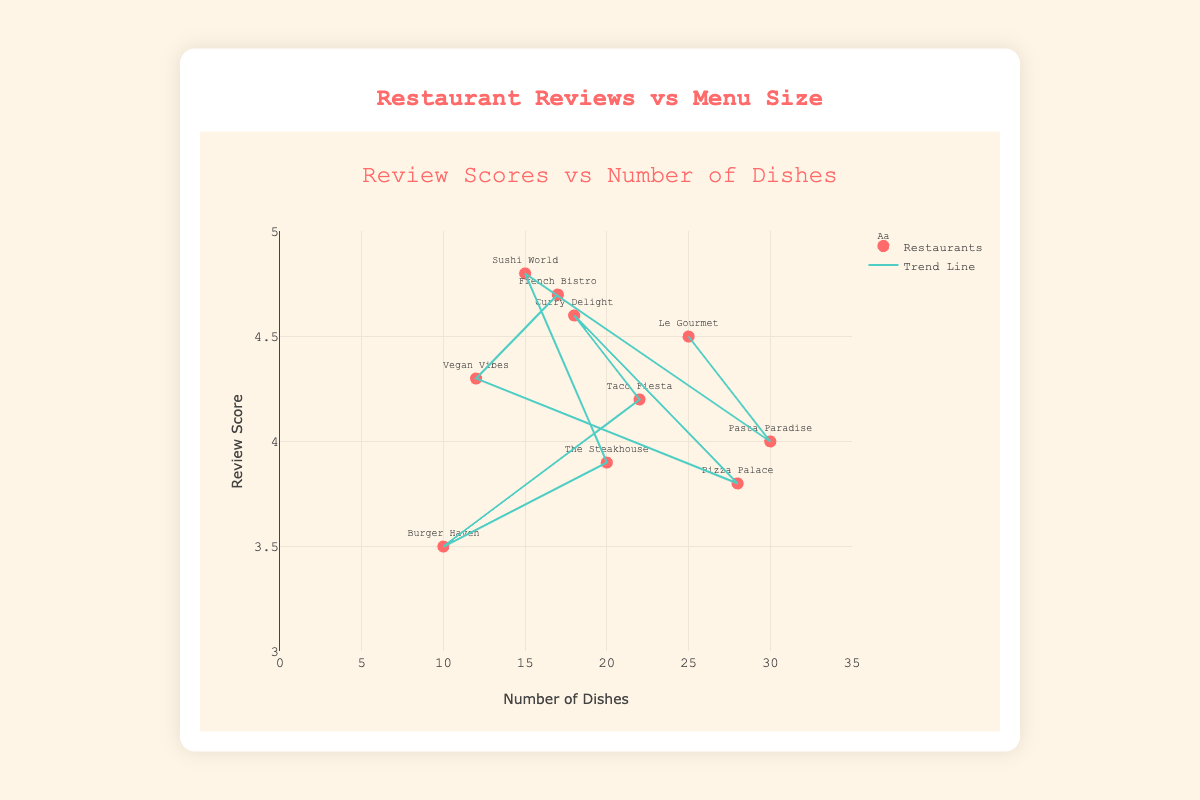How many restaurants are shown in the plot? Count each data point representing a restaurant in the plot. Each point corresponds to a restaurant, and there are 10 data points in total.
Answer: 10 Which restaurant has the highest review score? Look for the data point with the highest position on the y-axis. Sushi World has the highest review score of 4.8.
Answer: Sushi World Which restaurant has the fewest dishes? Look for the data point farthest to the left on the x-axis. Burger Haven has the fewest dishes with 10.
Answer: Burger Haven What is the general trend between the number of dishes and review scores? Observe the trend line that indicates the general relationship between the two variables. The trend line appears to be relatively flat, indicating no strong correlation.
Answer: No strong correlation How many restaurants have a review score greater than 4.5? Identify the points above the 4.5 mark on the y-axis. There are 3 restaurants: Sushi World, Curry Delight, and French Bistro.
Answer: 3 Which restaurant has more dishes, Pasta Paradise or Vegan Vibes? Compare the positions of Pasta Paradise and Vegan Vibes on the x-axis. Pasta Paradise has 30 dishes, and Vegan Vibes has 12 dishes.
Answer: Pasta Paradise What is the average review score of all restaurants? Sum all review scores and divide by the number of restaurants: (4.5 + 4.0 + 4.8 + 3.9 + 3.5 + 4.2 + 4.6 + 3.8 + 4.3 + 4.7) / 10 = 42.3 / 10 = 4.23.
Answer: 4.23 If you choose two restaurants at random, what's the probability both have a review score above 4.0? Count the restaurants with a review score above 4.0 (6 restaurants). The probability is (6/10) * (5/9) = 1/3.
Answer: 1/3 Which restaurant has a review score closer to the average, Le Gourmet or Taco Fiesta? The average score is 4.23. Le Gourmet's score is 4.5, and Taco Fiesta's score is 4.2. The difference for Le Gourmet is 0.27, for Taco Fiesta is 0.03.
Answer: Taco Fiesta Is there any restaurant with a review score of exactly 4.0? Look for any point exactly on the y-axis value of 4.0. Pasta Paradise has a review score of 4.0.
Answer: Yes 